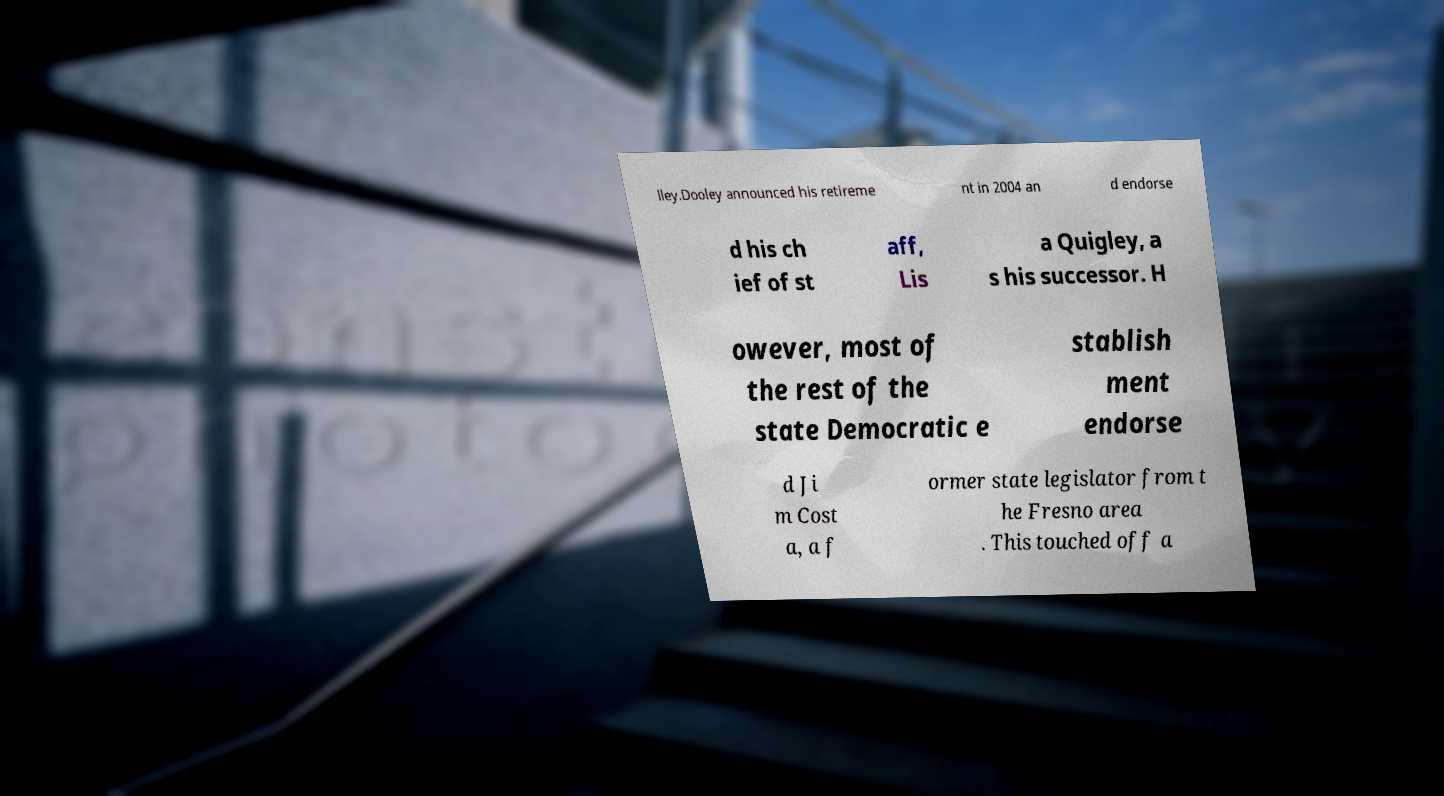Can you accurately transcribe the text from the provided image for me? lley.Dooley announced his retireme nt in 2004 an d endorse d his ch ief of st aff, Lis a Quigley, a s his successor. H owever, most of the rest of the state Democratic e stablish ment endorse d Ji m Cost a, a f ormer state legislator from t he Fresno area . This touched off a 